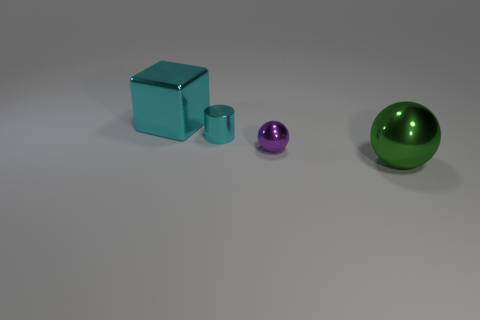Add 1 cyan metal objects. How many objects exist? 5 Add 2 green rubber blocks. How many green rubber blocks exist? 2 Subtract 1 cyan blocks. How many objects are left? 3 Subtract all small green metal balls. Subtract all purple spheres. How many objects are left? 3 Add 2 cyan objects. How many cyan objects are left? 4 